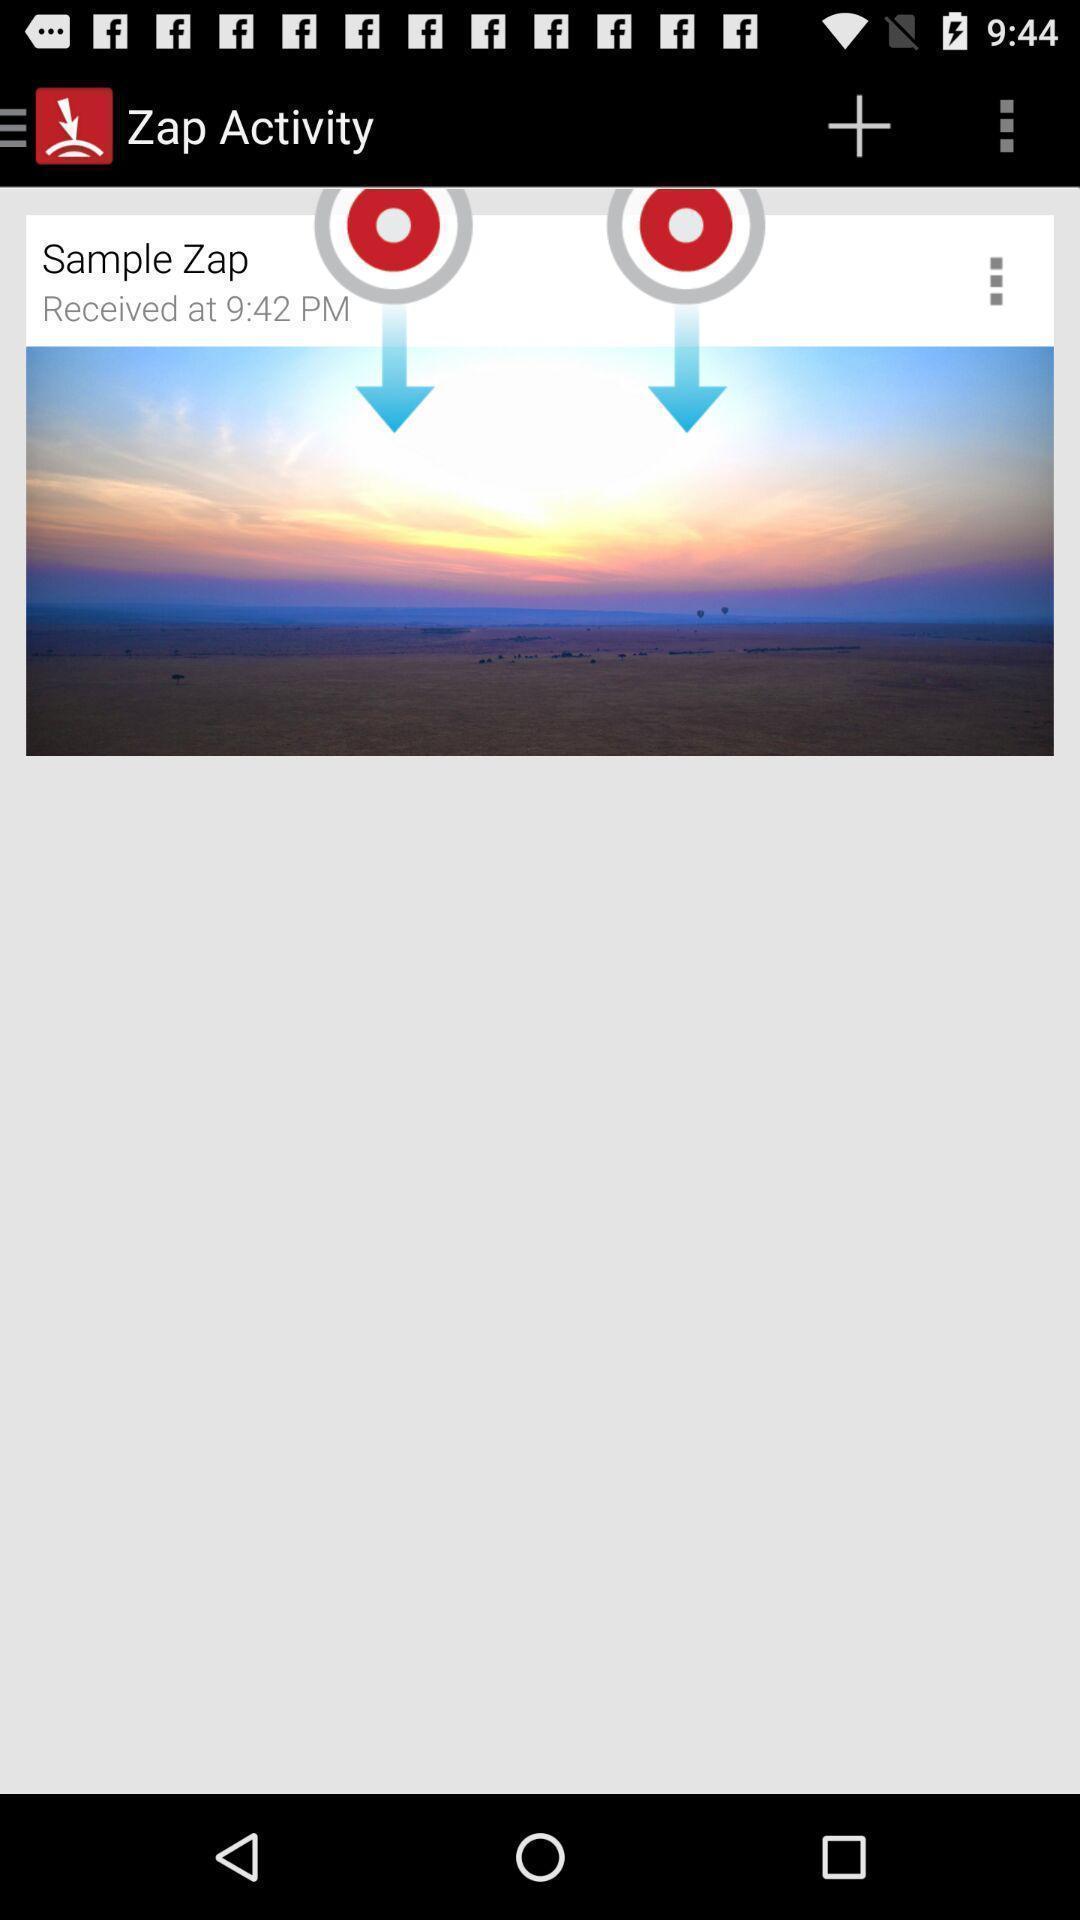Describe the content in this image. Zap activity application with sample document. 